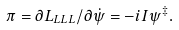<formula> <loc_0><loc_0><loc_500><loc_500>\pi = \partial L _ { L L L } / \partial \dot { \psi } = - i I \psi ^ { \ddagger } .</formula> 